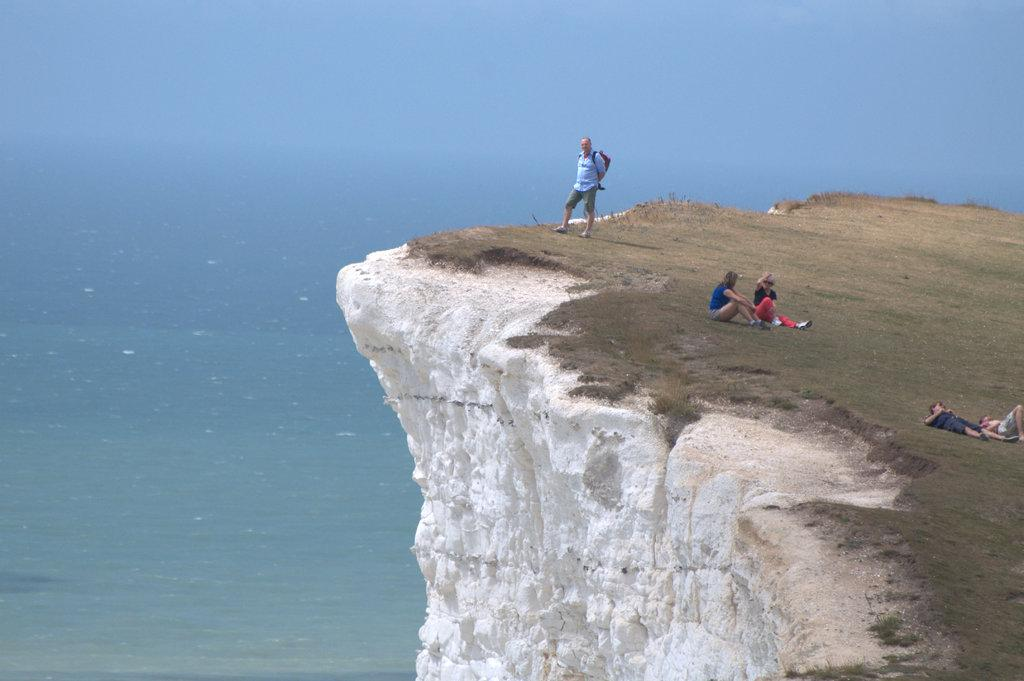What is the location of the people in the image? The people are on a rock in the image. What can be seen in the background of the image? There is water visible in the image. Can you describe the clothing of one of the people? One person is wearing a bag. What type of patch can be seen on the robin's wing in the image? There is no robin present in the image, so there is no patch to observe on its wing. 